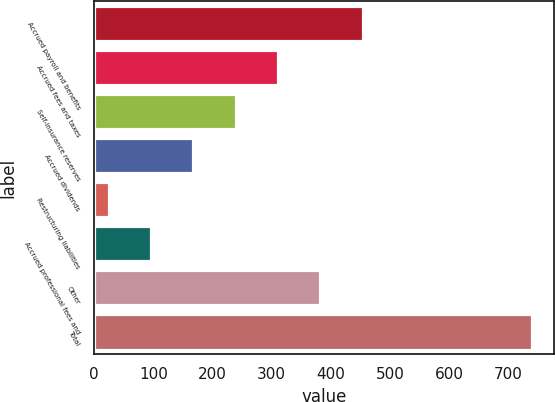Convert chart to OTSL. <chart><loc_0><loc_0><loc_500><loc_500><bar_chart><fcel>Accrued payroll and benefits<fcel>Accrued fees and taxes<fcel>Self-insurance reserves<fcel>Accrued dividends<fcel>Restructuring liabilities<fcel>Accrued professional fees and<fcel>Other<fcel>Total<nl><fcel>454.04<fcel>310.96<fcel>239.42<fcel>167.88<fcel>24.8<fcel>96.34<fcel>382.5<fcel>740.2<nl></chart> 